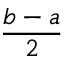Convert formula to latex. <formula><loc_0><loc_0><loc_500><loc_500>\frac { b - a } { 2 }</formula> 